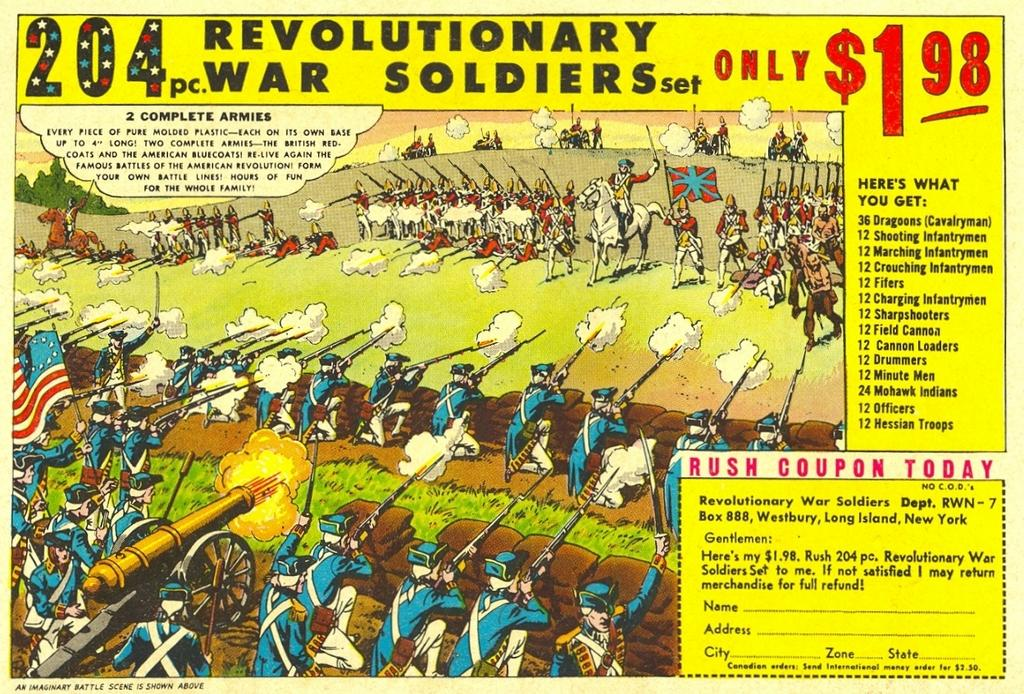What is featured in the image? There is a poster in the image. What can be found on the poster? There is text on the poster. What type of characters are present in the image? There are animated characters in the image. What type of art can be seen in the eye of the animated character in the image? There is no eye or art present in the image; it features a poster with text and animated characters. 